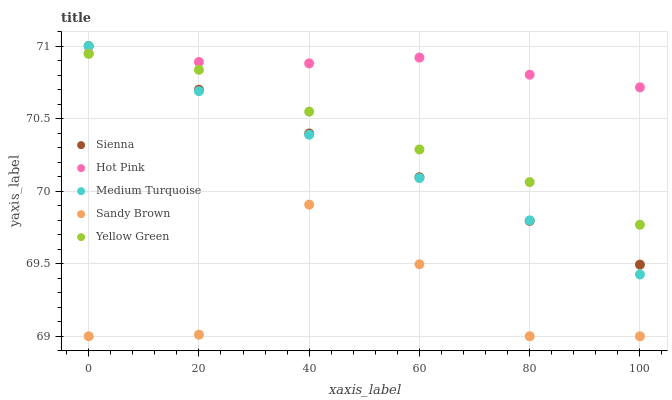Does Sandy Brown have the minimum area under the curve?
Answer yes or no. Yes. Does Hot Pink have the maximum area under the curve?
Answer yes or no. Yes. Does Hot Pink have the minimum area under the curve?
Answer yes or no. No. Does Sandy Brown have the maximum area under the curve?
Answer yes or no. No. Is Sienna the smoothest?
Answer yes or no. Yes. Is Sandy Brown the roughest?
Answer yes or no. Yes. Is Hot Pink the smoothest?
Answer yes or no. No. Is Hot Pink the roughest?
Answer yes or no. No. Does Sandy Brown have the lowest value?
Answer yes or no. Yes. Does Hot Pink have the lowest value?
Answer yes or no. No. Does Medium Turquoise have the highest value?
Answer yes or no. Yes. Does Hot Pink have the highest value?
Answer yes or no. No. Is Sandy Brown less than Medium Turquoise?
Answer yes or no. Yes. Is Hot Pink greater than Sandy Brown?
Answer yes or no. Yes. Does Sienna intersect Yellow Green?
Answer yes or no. Yes. Is Sienna less than Yellow Green?
Answer yes or no. No. Is Sienna greater than Yellow Green?
Answer yes or no. No. Does Sandy Brown intersect Medium Turquoise?
Answer yes or no. No. 